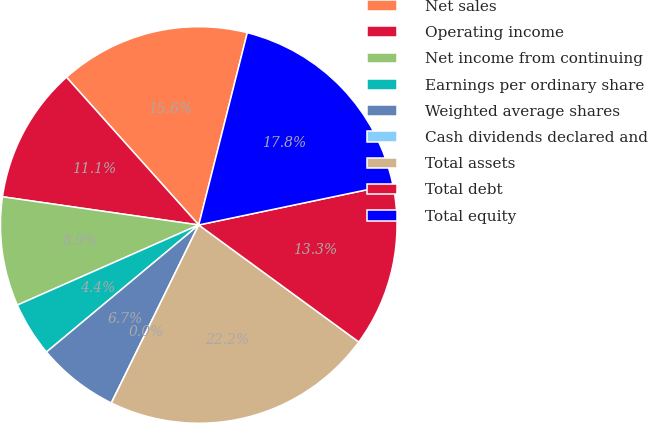Convert chart. <chart><loc_0><loc_0><loc_500><loc_500><pie_chart><fcel>Net sales<fcel>Operating income<fcel>Net income from continuing<fcel>Earnings per ordinary share<fcel>Weighted average shares<fcel>Cash dividends declared and<fcel>Total assets<fcel>Total debt<fcel>Total equity<nl><fcel>15.56%<fcel>11.11%<fcel>8.89%<fcel>4.45%<fcel>6.67%<fcel>0.0%<fcel>22.22%<fcel>13.33%<fcel>17.78%<nl></chart> 